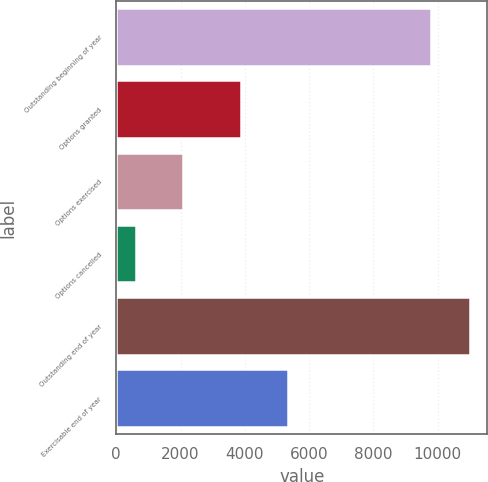<chart> <loc_0><loc_0><loc_500><loc_500><bar_chart><fcel>Outstanding beginning of year<fcel>Options granted<fcel>Options exercised<fcel>Options cancelled<fcel>Outstanding end of year<fcel>Exercisable end of year<nl><fcel>9794<fcel>3884<fcel>2085<fcel>601<fcel>10992<fcel>5346<nl></chart> 